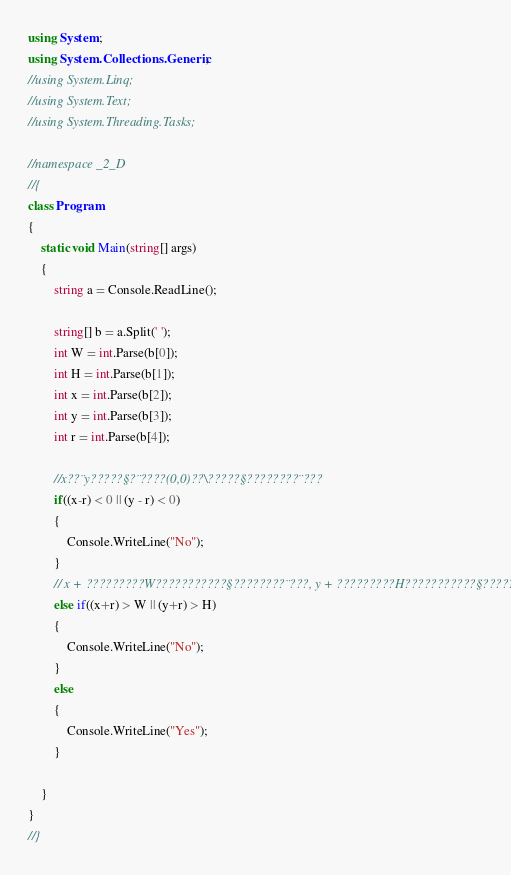<code> <loc_0><loc_0><loc_500><loc_500><_C#_>using System;
using System.Collections.Generic;
//using System.Linq;
//using System.Text;
//using System.Threading.Tasks;

//namespace _2_D
//{
class Program
{
    static void Main(string[] args)
    {
        string a = Console.ReadLine();

        string[] b = a.Split(' ');
        int W = int.Parse(b[0]);
        int H = int.Parse(b[1]);
        int x = int.Parse(b[2]);
        int y = int.Parse(b[3]);
        int r = int.Parse(b[4]);

        //x??¨y?????§?¨????(0,0)??\?????§????????¨???
        if((x-r) < 0 || (y - r) < 0)
        {
            Console.WriteLine("No");
        }
        // x + ?????????W???????????§????????¨???, y + ?????????H???????????§??????
        else if((x+r) > W || (y+r) > H)
        {
            Console.WriteLine("No");
        }
        else
        {
            Console.WriteLine("Yes");
        }

    }
}
//}</code> 